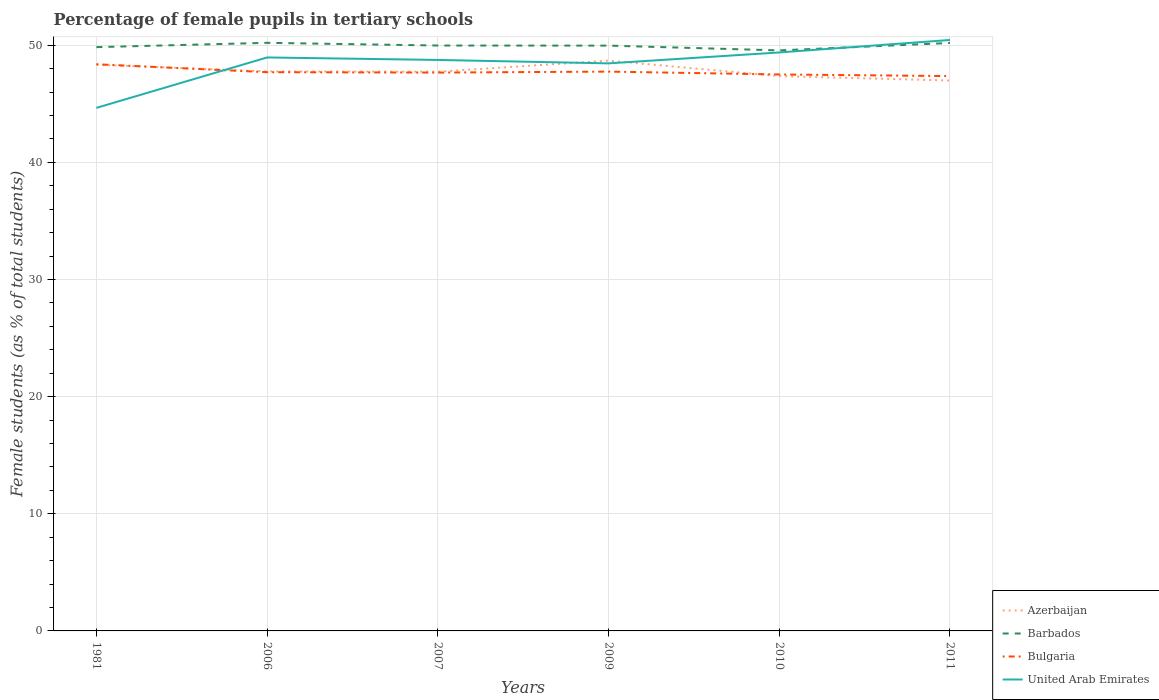How many different coloured lines are there?
Provide a short and direct response. 4. Across all years, what is the maximum percentage of female pupils in tertiary schools in Azerbaijan?
Provide a succinct answer. 46.99. What is the total percentage of female pupils in tertiary schools in Azerbaijan in the graph?
Offer a terse response. -0.92. What is the difference between the highest and the second highest percentage of female pupils in tertiary schools in Bulgaria?
Give a very brief answer. 1.01. What is the difference between the highest and the lowest percentage of female pupils in tertiary schools in United Arab Emirates?
Give a very brief answer. 5. Is the percentage of female pupils in tertiary schools in Bulgaria strictly greater than the percentage of female pupils in tertiary schools in Azerbaijan over the years?
Ensure brevity in your answer.  No. How many lines are there?
Make the answer very short. 4. Are the values on the major ticks of Y-axis written in scientific E-notation?
Provide a succinct answer. No. What is the title of the graph?
Make the answer very short. Percentage of female pupils in tertiary schools. What is the label or title of the X-axis?
Offer a very short reply. Years. What is the label or title of the Y-axis?
Your response must be concise. Female students (as % of total students). What is the Female students (as % of total students) in Azerbaijan in 1981?
Your answer should be very brief. 48.34. What is the Female students (as % of total students) in Barbados in 1981?
Your response must be concise. 49.84. What is the Female students (as % of total students) in Bulgaria in 1981?
Ensure brevity in your answer.  48.38. What is the Female students (as % of total students) of United Arab Emirates in 1981?
Keep it short and to the point. 44.65. What is the Female students (as % of total students) of Azerbaijan in 2006?
Give a very brief answer. 47.77. What is the Female students (as % of total students) of Barbados in 2006?
Your answer should be very brief. 50.21. What is the Female students (as % of total students) in Bulgaria in 2006?
Provide a short and direct response. 47.7. What is the Female students (as % of total students) of United Arab Emirates in 2006?
Provide a succinct answer. 48.96. What is the Female students (as % of total students) of Azerbaijan in 2007?
Offer a terse response. 47.74. What is the Female students (as % of total students) of Barbados in 2007?
Make the answer very short. 49.98. What is the Female students (as % of total students) of Bulgaria in 2007?
Your answer should be compact. 47.67. What is the Female students (as % of total students) in United Arab Emirates in 2007?
Ensure brevity in your answer.  48.75. What is the Female students (as % of total students) in Azerbaijan in 2009?
Ensure brevity in your answer.  48.69. What is the Female students (as % of total students) of Barbados in 2009?
Keep it short and to the point. 49.97. What is the Female students (as % of total students) of Bulgaria in 2009?
Your answer should be very brief. 47.75. What is the Female students (as % of total students) of United Arab Emirates in 2009?
Provide a short and direct response. 48.46. What is the Female students (as % of total students) in Azerbaijan in 2010?
Your answer should be very brief. 47.37. What is the Female students (as % of total students) in Barbados in 2010?
Provide a succinct answer. 49.56. What is the Female students (as % of total students) of Bulgaria in 2010?
Offer a terse response. 47.51. What is the Female students (as % of total students) in United Arab Emirates in 2010?
Provide a short and direct response. 49.39. What is the Female students (as % of total students) of Azerbaijan in 2011?
Your response must be concise. 46.99. What is the Female students (as % of total students) of Barbados in 2011?
Offer a very short reply. 50.2. What is the Female students (as % of total students) in Bulgaria in 2011?
Keep it short and to the point. 47.37. What is the Female students (as % of total students) of United Arab Emirates in 2011?
Ensure brevity in your answer.  50.45. Across all years, what is the maximum Female students (as % of total students) of Azerbaijan?
Ensure brevity in your answer.  48.69. Across all years, what is the maximum Female students (as % of total students) in Barbados?
Provide a succinct answer. 50.21. Across all years, what is the maximum Female students (as % of total students) of Bulgaria?
Give a very brief answer. 48.38. Across all years, what is the maximum Female students (as % of total students) of United Arab Emirates?
Make the answer very short. 50.45. Across all years, what is the minimum Female students (as % of total students) in Azerbaijan?
Your response must be concise. 46.99. Across all years, what is the minimum Female students (as % of total students) of Barbados?
Your response must be concise. 49.56. Across all years, what is the minimum Female students (as % of total students) of Bulgaria?
Offer a terse response. 47.37. Across all years, what is the minimum Female students (as % of total students) of United Arab Emirates?
Give a very brief answer. 44.65. What is the total Female students (as % of total students) of Azerbaijan in the graph?
Provide a short and direct response. 286.9. What is the total Female students (as % of total students) of Barbados in the graph?
Ensure brevity in your answer.  299.76. What is the total Female students (as % of total students) in Bulgaria in the graph?
Your answer should be very brief. 286.38. What is the total Female students (as % of total students) of United Arab Emirates in the graph?
Ensure brevity in your answer.  290.66. What is the difference between the Female students (as % of total students) in Azerbaijan in 1981 and that in 2006?
Offer a very short reply. 0.57. What is the difference between the Female students (as % of total students) of Barbados in 1981 and that in 2006?
Your answer should be very brief. -0.37. What is the difference between the Female students (as % of total students) of Bulgaria in 1981 and that in 2006?
Give a very brief answer. 0.68. What is the difference between the Female students (as % of total students) in United Arab Emirates in 1981 and that in 2006?
Provide a short and direct response. -4.3. What is the difference between the Female students (as % of total students) of Azerbaijan in 1981 and that in 2007?
Make the answer very short. 0.59. What is the difference between the Female students (as % of total students) of Barbados in 1981 and that in 2007?
Make the answer very short. -0.14. What is the difference between the Female students (as % of total students) in Bulgaria in 1981 and that in 2007?
Ensure brevity in your answer.  0.71. What is the difference between the Female students (as % of total students) in United Arab Emirates in 1981 and that in 2007?
Ensure brevity in your answer.  -4.09. What is the difference between the Female students (as % of total students) in Azerbaijan in 1981 and that in 2009?
Your answer should be compact. -0.35. What is the difference between the Female students (as % of total students) of Barbados in 1981 and that in 2009?
Keep it short and to the point. -0.13. What is the difference between the Female students (as % of total students) of Bulgaria in 1981 and that in 2009?
Ensure brevity in your answer.  0.63. What is the difference between the Female students (as % of total students) of United Arab Emirates in 1981 and that in 2009?
Offer a terse response. -3.8. What is the difference between the Female students (as % of total students) in Azerbaijan in 1981 and that in 2010?
Your answer should be compact. 0.97. What is the difference between the Female students (as % of total students) of Barbados in 1981 and that in 2010?
Offer a very short reply. 0.28. What is the difference between the Female students (as % of total students) in Bulgaria in 1981 and that in 2010?
Ensure brevity in your answer.  0.87. What is the difference between the Female students (as % of total students) in United Arab Emirates in 1981 and that in 2010?
Your response must be concise. -4.73. What is the difference between the Female students (as % of total students) of Azerbaijan in 1981 and that in 2011?
Keep it short and to the point. 1.35. What is the difference between the Female students (as % of total students) of Barbados in 1981 and that in 2011?
Your answer should be very brief. -0.36. What is the difference between the Female students (as % of total students) in Bulgaria in 1981 and that in 2011?
Offer a very short reply. 1.01. What is the difference between the Female students (as % of total students) of United Arab Emirates in 1981 and that in 2011?
Make the answer very short. -5.8. What is the difference between the Female students (as % of total students) of Azerbaijan in 2006 and that in 2007?
Offer a very short reply. 0.02. What is the difference between the Female students (as % of total students) in Barbados in 2006 and that in 2007?
Provide a succinct answer. 0.23. What is the difference between the Female students (as % of total students) of Bulgaria in 2006 and that in 2007?
Provide a short and direct response. 0.03. What is the difference between the Female students (as % of total students) in United Arab Emirates in 2006 and that in 2007?
Offer a very short reply. 0.21. What is the difference between the Female students (as % of total students) in Azerbaijan in 2006 and that in 2009?
Your response must be concise. -0.92. What is the difference between the Female students (as % of total students) in Barbados in 2006 and that in 2009?
Your answer should be very brief. 0.24. What is the difference between the Female students (as % of total students) of Bulgaria in 2006 and that in 2009?
Provide a succinct answer. -0.05. What is the difference between the Female students (as % of total students) in United Arab Emirates in 2006 and that in 2009?
Provide a short and direct response. 0.5. What is the difference between the Female students (as % of total students) in Azerbaijan in 2006 and that in 2010?
Ensure brevity in your answer.  0.4. What is the difference between the Female students (as % of total students) of Barbados in 2006 and that in 2010?
Provide a short and direct response. 0.65. What is the difference between the Female students (as % of total students) in Bulgaria in 2006 and that in 2010?
Provide a succinct answer. 0.2. What is the difference between the Female students (as % of total students) of United Arab Emirates in 2006 and that in 2010?
Give a very brief answer. -0.43. What is the difference between the Female students (as % of total students) of Azerbaijan in 2006 and that in 2011?
Make the answer very short. 0.78. What is the difference between the Female students (as % of total students) in Barbados in 2006 and that in 2011?
Provide a short and direct response. 0.01. What is the difference between the Female students (as % of total students) of Bulgaria in 2006 and that in 2011?
Your answer should be very brief. 0.33. What is the difference between the Female students (as % of total students) of United Arab Emirates in 2006 and that in 2011?
Your answer should be compact. -1.49. What is the difference between the Female students (as % of total students) of Azerbaijan in 2007 and that in 2009?
Offer a very short reply. -0.94. What is the difference between the Female students (as % of total students) of Barbados in 2007 and that in 2009?
Your answer should be very brief. 0.01. What is the difference between the Female students (as % of total students) of Bulgaria in 2007 and that in 2009?
Your response must be concise. -0.08. What is the difference between the Female students (as % of total students) of United Arab Emirates in 2007 and that in 2009?
Ensure brevity in your answer.  0.29. What is the difference between the Female students (as % of total students) in Azerbaijan in 2007 and that in 2010?
Provide a succinct answer. 0.38. What is the difference between the Female students (as % of total students) of Barbados in 2007 and that in 2010?
Offer a terse response. 0.42. What is the difference between the Female students (as % of total students) of Bulgaria in 2007 and that in 2010?
Your answer should be very brief. 0.16. What is the difference between the Female students (as % of total students) of United Arab Emirates in 2007 and that in 2010?
Keep it short and to the point. -0.64. What is the difference between the Female students (as % of total students) in Azerbaijan in 2007 and that in 2011?
Make the answer very short. 0.75. What is the difference between the Female students (as % of total students) of Barbados in 2007 and that in 2011?
Keep it short and to the point. -0.22. What is the difference between the Female students (as % of total students) in Bulgaria in 2007 and that in 2011?
Your response must be concise. 0.3. What is the difference between the Female students (as % of total students) of United Arab Emirates in 2007 and that in 2011?
Your response must be concise. -1.7. What is the difference between the Female students (as % of total students) of Azerbaijan in 2009 and that in 2010?
Ensure brevity in your answer.  1.32. What is the difference between the Female students (as % of total students) of Barbados in 2009 and that in 2010?
Your answer should be very brief. 0.41. What is the difference between the Female students (as % of total students) in Bulgaria in 2009 and that in 2010?
Make the answer very short. 0.24. What is the difference between the Female students (as % of total students) in United Arab Emirates in 2009 and that in 2010?
Ensure brevity in your answer.  -0.93. What is the difference between the Female students (as % of total students) in Azerbaijan in 2009 and that in 2011?
Give a very brief answer. 1.7. What is the difference between the Female students (as % of total students) in Barbados in 2009 and that in 2011?
Provide a succinct answer. -0.23. What is the difference between the Female students (as % of total students) of Bulgaria in 2009 and that in 2011?
Provide a succinct answer. 0.38. What is the difference between the Female students (as % of total students) of United Arab Emirates in 2009 and that in 2011?
Offer a very short reply. -2. What is the difference between the Female students (as % of total students) in Azerbaijan in 2010 and that in 2011?
Keep it short and to the point. 0.38. What is the difference between the Female students (as % of total students) of Barbados in 2010 and that in 2011?
Offer a terse response. -0.64. What is the difference between the Female students (as % of total students) of Bulgaria in 2010 and that in 2011?
Your answer should be very brief. 0.14. What is the difference between the Female students (as % of total students) of United Arab Emirates in 2010 and that in 2011?
Ensure brevity in your answer.  -1.07. What is the difference between the Female students (as % of total students) of Azerbaijan in 1981 and the Female students (as % of total students) of Barbados in 2006?
Your response must be concise. -1.87. What is the difference between the Female students (as % of total students) of Azerbaijan in 1981 and the Female students (as % of total students) of Bulgaria in 2006?
Offer a very short reply. 0.63. What is the difference between the Female students (as % of total students) of Azerbaijan in 1981 and the Female students (as % of total students) of United Arab Emirates in 2006?
Offer a very short reply. -0.62. What is the difference between the Female students (as % of total students) of Barbados in 1981 and the Female students (as % of total students) of Bulgaria in 2006?
Offer a terse response. 2.14. What is the difference between the Female students (as % of total students) in Barbados in 1981 and the Female students (as % of total students) in United Arab Emirates in 2006?
Your response must be concise. 0.88. What is the difference between the Female students (as % of total students) in Bulgaria in 1981 and the Female students (as % of total students) in United Arab Emirates in 2006?
Offer a terse response. -0.58. What is the difference between the Female students (as % of total students) in Azerbaijan in 1981 and the Female students (as % of total students) in Barbados in 2007?
Make the answer very short. -1.64. What is the difference between the Female students (as % of total students) in Azerbaijan in 1981 and the Female students (as % of total students) in Bulgaria in 2007?
Keep it short and to the point. 0.67. What is the difference between the Female students (as % of total students) of Azerbaijan in 1981 and the Female students (as % of total students) of United Arab Emirates in 2007?
Provide a succinct answer. -0.41. What is the difference between the Female students (as % of total students) in Barbados in 1981 and the Female students (as % of total students) in Bulgaria in 2007?
Offer a very short reply. 2.17. What is the difference between the Female students (as % of total students) of Barbados in 1981 and the Female students (as % of total students) of United Arab Emirates in 2007?
Keep it short and to the point. 1.09. What is the difference between the Female students (as % of total students) in Bulgaria in 1981 and the Female students (as % of total students) in United Arab Emirates in 2007?
Your answer should be very brief. -0.37. What is the difference between the Female students (as % of total students) in Azerbaijan in 1981 and the Female students (as % of total students) in Barbados in 2009?
Your answer should be compact. -1.63. What is the difference between the Female students (as % of total students) in Azerbaijan in 1981 and the Female students (as % of total students) in Bulgaria in 2009?
Your response must be concise. 0.58. What is the difference between the Female students (as % of total students) of Azerbaijan in 1981 and the Female students (as % of total students) of United Arab Emirates in 2009?
Provide a short and direct response. -0.12. What is the difference between the Female students (as % of total students) in Barbados in 1981 and the Female students (as % of total students) in Bulgaria in 2009?
Make the answer very short. 2.09. What is the difference between the Female students (as % of total students) of Barbados in 1981 and the Female students (as % of total students) of United Arab Emirates in 2009?
Your response must be concise. 1.38. What is the difference between the Female students (as % of total students) of Bulgaria in 1981 and the Female students (as % of total students) of United Arab Emirates in 2009?
Keep it short and to the point. -0.08. What is the difference between the Female students (as % of total students) in Azerbaijan in 1981 and the Female students (as % of total students) in Barbados in 2010?
Offer a very short reply. -1.23. What is the difference between the Female students (as % of total students) of Azerbaijan in 1981 and the Female students (as % of total students) of Bulgaria in 2010?
Ensure brevity in your answer.  0.83. What is the difference between the Female students (as % of total students) in Azerbaijan in 1981 and the Female students (as % of total students) in United Arab Emirates in 2010?
Make the answer very short. -1.05. What is the difference between the Female students (as % of total students) of Barbados in 1981 and the Female students (as % of total students) of Bulgaria in 2010?
Provide a succinct answer. 2.33. What is the difference between the Female students (as % of total students) in Barbados in 1981 and the Female students (as % of total students) in United Arab Emirates in 2010?
Provide a succinct answer. 0.45. What is the difference between the Female students (as % of total students) in Bulgaria in 1981 and the Female students (as % of total students) in United Arab Emirates in 2010?
Make the answer very short. -1.01. What is the difference between the Female students (as % of total students) of Azerbaijan in 1981 and the Female students (as % of total students) of Barbados in 2011?
Your response must be concise. -1.86. What is the difference between the Female students (as % of total students) in Azerbaijan in 1981 and the Female students (as % of total students) in Bulgaria in 2011?
Your answer should be compact. 0.97. What is the difference between the Female students (as % of total students) in Azerbaijan in 1981 and the Female students (as % of total students) in United Arab Emirates in 2011?
Offer a very short reply. -2.12. What is the difference between the Female students (as % of total students) in Barbados in 1981 and the Female students (as % of total students) in Bulgaria in 2011?
Make the answer very short. 2.47. What is the difference between the Female students (as % of total students) of Barbados in 1981 and the Female students (as % of total students) of United Arab Emirates in 2011?
Offer a terse response. -0.61. What is the difference between the Female students (as % of total students) in Bulgaria in 1981 and the Female students (as % of total students) in United Arab Emirates in 2011?
Your answer should be very brief. -2.07. What is the difference between the Female students (as % of total students) of Azerbaijan in 2006 and the Female students (as % of total students) of Barbados in 2007?
Provide a short and direct response. -2.21. What is the difference between the Female students (as % of total students) in Azerbaijan in 2006 and the Female students (as % of total students) in Bulgaria in 2007?
Provide a succinct answer. 0.1. What is the difference between the Female students (as % of total students) of Azerbaijan in 2006 and the Female students (as % of total students) of United Arab Emirates in 2007?
Keep it short and to the point. -0.98. What is the difference between the Female students (as % of total students) of Barbados in 2006 and the Female students (as % of total students) of Bulgaria in 2007?
Offer a terse response. 2.54. What is the difference between the Female students (as % of total students) of Barbados in 2006 and the Female students (as % of total students) of United Arab Emirates in 2007?
Provide a succinct answer. 1.46. What is the difference between the Female students (as % of total students) of Bulgaria in 2006 and the Female students (as % of total students) of United Arab Emirates in 2007?
Provide a short and direct response. -1.05. What is the difference between the Female students (as % of total students) in Azerbaijan in 2006 and the Female students (as % of total students) in Barbados in 2009?
Your answer should be very brief. -2.2. What is the difference between the Female students (as % of total students) of Azerbaijan in 2006 and the Female students (as % of total students) of Bulgaria in 2009?
Your answer should be compact. 0.02. What is the difference between the Female students (as % of total students) in Azerbaijan in 2006 and the Female students (as % of total students) in United Arab Emirates in 2009?
Make the answer very short. -0.69. What is the difference between the Female students (as % of total students) of Barbados in 2006 and the Female students (as % of total students) of Bulgaria in 2009?
Your response must be concise. 2.46. What is the difference between the Female students (as % of total students) in Barbados in 2006 and the Female students (as % of total students) in United Arab Emirates in 2009?
Provide a short and direct response. 1.75. What is the difference between the Female students (as % of total students) of Bulgaria in 2006 and the Female students (as % of total students) of United Arab Emirates in 2009?
Provide a succinct answer. -0.75. What is the difference between the Female students (as % of total students) in Azerbaijan in 2006 and the Female students (as % of total students) in Barbados in 2010?
Offer a very short reply. -1.79. What is the difference between the Female students (as % of total students) of Azerbaijan in 2006 and the Female students (as % of total students) of Bulgaria in 2010?
Offer a terse response. 0.26. What is the difference between the Female students (as % of total students) in Azerbaijan in 2006 and the Female students (as % of total students) in United Arab Emirates in 2010?
Give a very brief answer. -1.62. What is the difference between the Female students (as % of total students) in Barbados in 2006 and the Female students (as % of total students) in Bulgaria in 2010?
Provide a short and direct response. 2.7. What is the difference between the Female students (as % of total students) of Barbados in 2006 and the Female students (as % of total students) of United Arab Emirates in 2010?
Offer a very short reply. 0.82. What is the difference between the Female students (as % of total students) in Bulgaria in 2006 and the Female students (as % of total students) in United Arab Emirates in 2010?
Your answer should be compact. -1.68. What is the difference between the Female students (as % of total students) of Azerbaijan in 2006 and the Female students (as % of total students) of Barbados in 2011?
Ensure brevity in your answer.  -2.43. What is the difference between the Female students (as % of total students) of Azerbaijan in 2006 and the Female students (as % of total students) of Bulgaria in 2011?
Offer a very short reply. 0.4. What is the difference between the Female students (as % of total students) of Azerbaijan in 2006 and the Female students (as % of total students) of United Arab Emirates in 2011?
Keep it short and to the point. -2.68. What is the difference between the Female students (as % of total students) of Barbados in 2006 and the Female students (as % of total students) of Bulgaria in 2011?
Provide a succinct answer. 2.84. What is the difference between the Female students (as % of total students) in Barbados in 2006 and the Female students (as % of total students) in United Arab Emirates in 2011?
Offer a very short reply. -0.24. What is the difference between the Female students (as % of total students) in Bulgaria in 2006 and the Female students (as % of total students) in United Arab Emirates in 2011?
Give a very brief answer. -2.75. What is the difference between the Female students (as % of total students) in Azerbaijan in 2007 and the Female students (as % of total students) in Barbados in 2009?
Your answer should be compact. -2.23. What is the difference between the Female students (as % of total students) in Azerbaijan in 2007 and the Female students (as % of total students) in Bulgaria in 2009?
Provide a succinct answer. -0.01. What is the difference between the Female students (as % of total students) in Azerbaijan in 2007 and the Female students (as % of total students) in United Arab Emirates in 2009?
Your answer should be compact. -0.71. What is the difference between the Female students (as % of total students) of Barbados in 2007 and the Female students (as % of total students) of Bulgaria in 2009?
Your answer should be very brief. 2.23. What is the difference between the Female students (as % of total students) in Barbados in 2007 and the Female students (as % of total students) in United Arab Emirates in 2009?
Offer a very short reply. 1.52. What is the difference between the Female students (as % of total students) in Bulgaria in 2007 and the Female students (as % of total students) in United Arab Emirates in 2009?
Provide a succinct answer. -0.79. What is the difference between the Female students (as % of total students) in Azerbaijan in 2007 and the Female students (as % of total students) in Barbados in 2010?
Make the answer very short. -1.82. What is the difference between the Female students (as % of total students) in Azerbaijan in 2007 and the Female students (as % of total students) in Bulgaria in 2010?
Make the answer very short. 0.24. What is the difference between the Female students (as % of total students) of Azerbaijan in 2007 and the Female students (as % of total students) of United Arab Emirates in 2010?
Your response must be concise. -1.64. What is the difference between the Female students (as % of total students) in Barbados in 2007 and the Female students (as % of total students) in Bulgaria in 2010?
Make the answer very short. 2.47. What is the difference between the Female students (as % of total students) of Barbados in 2007 and the Female students (as % of total students) of United Arab Emirates in 2010?
Provide a short and direct response. 0.59. What is the difference between the Female students (as % of total students) of Bulgaria in 2007 and the Female students (as % of total students) of United Arab Emirates in 2010?
Make the answer very short. -1.72. What is the difference between the Female students (as % of total students) in Azerbaijan in 2007 and the Female students (as % of total students) in Barbados in 2011?
Keep it short and to the point. -2.45. What is the difference between the Female students (as % of total students) of Azerbaijan in 2007 and the Female students (as % of total students) of Bulgaria in 2011?
Make the answer very short. 0.38. What is the difference between the Female students (as % of total students) in Azerbaijan in 2007 and the Female students (as % of total students) in United Arab Emirates in 2011?
Keep it short and to the point. -2.71. What is the difference between the Female students (as % of total students) in Barbados in 2007 and the Female students (as % of total students) in Bulgaria in 2011?
Offer a terse response. 2.61. What is the difference between the Female students (as % of total students) of Barbados in 2007 and the Female students (as % of total students) of United Arab Emirates in 2011?
Offer a terse response. -0.47. What is the difference between the Female students (as % of total students) of Bulgaria in 2007 and the Female students (as % of total students) of United Arab Emirates in 2011?
Your answer should be compact. -2.78. What is the difference between the Female students (as % of total students) in Azerbaijan in 2009 and the Female students (as % of total students) in Barbados in 2010?
Offer a very short reply. -0.87. What is the difference between the Female students (as % of total students) in Azerbaijan in 2009 and the Female students (as % of total students) in Bulgaria in 2010?
Give a very brief answer. 1.18. What is the difference between the Female students (as % of total students) of Azerbaijan in 2009 and the Female students (as % of total students) of United Arab Emirates in 2010?
Your answer should be compact. -0.7. What is the difference between the Female students (as % of total students) in Barbados in 2009 and the Female students (as % of total students) in Bulgaria in 2010?
Provide a short and direct response. 2.46. What is the difference between the Female students (as % of total students) of Barbados in 2009 and the Female students (as % of total students) of United Arab Emirates in 2010?
Ensure brevity in your answer.  0.58. What is the difference between the Female students (as % of total students) in Bulgaria in 2009 and the Female students (as % of total students) in United Arab Emirates in 2010?
Your answer should be compact. -1.64. What is the difference between the Female students (as % of total students) in Azerbaijan in 2009 and the Female students (as % of total students) in Barbados in 2011?
Give a very brief answer. -1.51. What is the difference between the Female students (as % of total students) of Azerbaijan in 2009 and the Female students (as % of total students) of Bulgaria in 2011?
Keep it short and to the point. 1.32. What is the difference between the Female students (as % of total students) of Azerbaijan in 2009 and the Female students (as % of total students) of United Arab Emirates in 2011?
Provide a short and direct response. -1.76. What is the difference between the Female students (as % of total students) of Barbados in 2009 and the Female students (as % of total students) of Bulgaria in 2011?
Ensure brevity in your answer.  2.6. What is the difference between the Female students (as % of total students) of Barbados in 2009 and the Female students (as % of total students) of United Arab Emirates in 2011?
Make the answer very short. -0.48. What is the difference between the Female students (as % of total students) in Bulgaria in 2009 and the Female students (as % of total students) in United Arab Emirates in 2011?
Your answer should be compact. -2.7. What is the difference between the Female students (as % of total students) in Azerbaijan in 2010 and the Female students (as % of total students) in Barbados in 2011?
Your answer should be compact. -2.83. What is the difference between the Female students (as % of total students) of Azerbaijan in 2010 and the Female students (as % of total students) of Bulgaria in 2011?
Provide a short and direct response. -0. What is the difference between the Female students (as % of total students) in Azerbaijan in 2010 and the Female students (as % of total students) in United Arab Emirates in 2011?
Offer a very short reply. -3.09. What is the difference between the Female students (as % of total students) in Barbados in 2010 and the Female students (as % of total students) in Bulgaria in 2011?
Your answer should be compact. 2.19. What is the difference between the Female students (as % of total students) of Barbados in 2010 and the Female students (as % of total students) of United Arab Emirates in 2011?
Give a very brief answer. -0.89. What is the difference between the Female students (as % of total students) of Bulgaria in 2010 and the Female students (as % of total students) of United Arab Emirates in 2011?
Your answer should be compact. -2.95. What is the average Female students (as % of total students) in Azerbaijan per year?
Provide a short and direct response. 47.82. What is the average Female students (as % of total students) of Barbados per year?
Make the answer very short. 49.96. What is the average Female students (as % of total students) of Bulgaria per year?
Your answer should be very brief. 47.73. What is the average Female students (as % of total students) in United Arab Emirates per year?
Make the answer very short. 48.44. In the year 1981, what is the difference between the Female students (as % of total students) of Azerbaijan and Female students (as % of total students) of Barbados?
Give a very brief answer. -1.5. In the year 1981, what is the difference between the Female students (as % of total students) of Azerbaijan and Female students (as % of total students) of Bulgaria?
Offer a terse response. -0.04. In the year 1981, what is the difference between the Female students (as % of total students) of Azerbaijan and Female students (as % of total students) of United Arab Emirates?
Offer a terse response. 3.68. In the year 1981, what is the difference between the Female students (as % of total students) in Barbados and Female students (as % of total students) in Bulgaria?
Your answer should be very brief. 1.46. In the year 1981, what is the difference between the Female students (as % of total students) of Barbados and Female students (as % of total students) of United Arab Emirates?
Provide a succinct answer. 5.19. In the year 1981, what is the difference between the Female students (as % of total students) in Bulgaria and Female students (as % of total students) in United Arab Emirates?
Provide a short and direct response. 3.73. In the year 2006, what is the difference between the Female students (as % of total students) of Azerbaijan and Female students (as % of total students) of Barbados?
Give a very brief answer. -2.44. In the year 2006, what is the difference between the Female students (as % of total students) of Azerbaijan and Female students (as % of total students) of Bulgaria?
Your answer should be compact. 0.07. In the year 2006, what is the difference between the Female students (as % of total students) of Azerbaijan and Female students (as % of total students) of United Arab Emirates?
Ensure brevity in your answer.  -1.19. In the year 2006, what is the difference between the Female students (as % of total students) of Barbados and Female students (as % of total students) of Bulgaria?
Your answer should be compact. 2.51. In the year 2006, what is the difference between the Female students (as % of total students) in Barbados and Female students (as % of total students) in United Arab Emirates?
Ensure brevity in your answer.  1.25. In the year 2006, what is the difference between the Female students (as % of total students) in Bulgaria and Female students (as % of total students) in United Arab Emirates?
Keep it short and to the point. -1.26. In the year 2007, what is the difference between the Female students (as % of total students) in Azerbaijan and Female students (as % of total students) in Barbados?
Keep it short and to the point. -2.23. In the year 2007, what is the difference between the Female students (as % of total students) of Azerbaijan and Female students (as % of total students) of Bulgaria?
Offer a very short reply. 0.08. In the year 2007, what is the difference between the Female students (as % of total students) of Azerbaijan and Female students (as % of total students) of United Arab Emirates?
Your answer should be compact. -1. In the year 2007, what is the difference between the Female students (as % of total students) of Barbados and Female students (as % of total students) of Bulgaria?
Give a very brief answer. 2.31. In the year 2007, what is the difference between the Female students (as % of total students) in Barbados and Female students (as % of total students) in United Arab Emirates?
Provide a short and direct response. 1.23. In the year 2007, what is the difference between the Female students (as % of total students) in Bulgaria and Female students (as % of total students) in United Arab Emirates?
Give a very brief answer. -1.08. In the year 2009, what is the difference between the Female students (as % of total students) of Azerbaijan and Female students (as % of total students) of Barbados?
Offer a terse response. -1.28. In the year 2009, what is the difference between the Female students (as % of total students) of Azerbaijan and Female students (as % of total students) of Bulgaria?
Your answer should be very brief. 0.94. In the year 2009, what is the difference between the Female students (as % of total students) of Azerbaijan and Female students (as % of total students) of United Arab Emirates?
Offer a very short reply. 0.23. In the year 2009, what is the difference between the Female students (as % of total students) in Barbados and Female students (as % of total students) in Bulgaria?
Your answer should be very brief. 2.22. In the year 2009, what is the difference between the Female students (as % of total students) in Barbados and Female students (as % of total students) in United Arab Emirates?
Offer a terse response. 1.51. In the year 2009, what is the difference between the Female students (as % of total students) of Bulgaria and Female students (as % of total students) of United Arab Emirates?
Keep it short and to the point. -0.7. In the year 2010, what is the difference between the Female students (as % of total students) of Azerbaijan and Female students (as % of total students) of Barbados?
Keep it short and to the point. -2.19. In the year 2010, what is the difference between the Female students (as % of total students) in Azerbaijan and Female students (as % of total students) in Bulgaria?
Keep it short and to the point. -0.14. In the year 2010, what is the difference between the Female students (as % of total students) of Azerbaijan and Female students (as % of total students) of United Arab Emirates?
Your answer should be compact. -2.02. In the year 2010, what is the difference between the Female students (as % of total students) of Barbados and Female students (as % of total students) of Bulgaria?
Your answer should be compact. 2.05. In the year 2010, what is the difference between the Female students (as % of total students) of Barbados and Female students (as % of total students) of United Arab Emirates?
Offer a terse response. 0.17. In the year 2010, what is the difference between the Female students (as % of total students) of Bulgaria and Female students (as % of total students) of United Arab Emirates?
Make the answer very short. -1.88. In the year 2011, what is the difference between the Female students (as % of total students) of Azerbaijan and Female students (as % of total students) of Barbados?
Provide a succinct answer. -3.21. In the year 2011, what is the difference between the Female students (as % of total students) of Azerbaijan and Female students (as % of total students) of Bulgaria?
Keep it short and to the point. -0.38. In the year 2011, what is the difference between the Female students (as % of total students) in Azerbaijan and Female students (as % of total students) in United Arab Emirates?
Offer a very short reply. -3.46. In the year 2011, what is the difference between the Female students (as % of total students) of Barbados and Female students (as % of total students) of Bulgaria?
Provide a short and direct response. 2.83. In the year 2011, what is the difference between the Female students (as % of total students) in Barbados and Female students (as % of total students) in United Arab Emirates?
Give a very brief answer. -0.25. In the year 2011, what is the difference between the Female students (as % of total students) of Bulgaria and Female students (as % of total students) of United Arab Emirates?
Ensure brevity in your answer.  -3.08. What is the ratio of the Female students (as % of total students) of Azerbaijan in 1981 to that in 2006?
Offer a terse response. 1.01. What is the ratio of the Female students (as % of total students) of Barbados in 1981 to that in 2006?
Your response must be concise. 0.99. What is the ratio of the Female students (as % of total students) of Bulgaria in 1981 to that in 2006?
Offer a very short reply. 1.01. What is the ratio of the Female students (as % of total students) in United Arab Emirates in 1981 to that in 2006?
Your answer should be very brief. 0.91. What is the ratio of the Female students (as % of total students) of Azerbaijan in 1981 to that in 2007?
Offer a very short reply. 1.01. What is the ratio of the Female students (as % of total students) of Bulgaria in 1981 to that in 2007?
Provide a succinct answer. 1.01. What is the ratio of the Female students (as % of total students) of United Arab Emirates in 1981 to that in 2007?
Make the answer very short. 0.92. What is the ratio of the Female students (as % of total students) in Barbados in 1981 to that in 2009?
Offer a very short reply. 1. What is the ratio of the Female students (as % of total students) of Bulgaria in 1981 to that in 2009?
Keep it short and to the point. 1.01. What is the ratio of the Female students (as % of total students) of United Arab Emirates in 1981 to that in 2009?
Ensure brevity in your answer.  0.92. What is the ratio of the Female students (as % of total students) of Azerbaijan in 1981 to that in 2010?
Provide a short and direct response. 1.02. What is the ratio of the Female students (as % of total students) of Barbados in 1981 to that in 2010?
Give a very brief answer. 1.01. What is the ratio of the Female students (as % of total students) in Bulgaria in 1981 to that in 2010?
Your answer should be very brief. 1.02. What is the ratio of the Female students (as % of total students) of United Arab Emirates in 1981 to that in 2010?
Offer a terse response. 0.9. What is the ratio of the Female students (as % of total students) in Azerbaijan in 1981 to that in 2011?
Provide a succinct answer. 1.03. What is the ratio of the Female students (as % of total students) in Barbados in 1981 to that in 2011?
Give a very brief answer. 0.99. What is the ratio of the Female students (as % of total students) in Bulgaria in 1981 to that in 2011?
Keep it short and to the point. 1.02. What is the ratio of the Female students (as % of total students) of United Arab Emirates in 1981 to that in 2011?
Offer a terse response. 0.89. What is the ratio of the Female students (as % of total students) in Azerbaijan in 2006 to that in 2007?
Your answer should be very brief. 1. What is the ratio of the Female students (as % of total students) in Barbados in 2006 to that in 2007?
Offer a terse response. 1. What is the ratio of the Female students (as % of total students) in Bulgaria in 2006 to that in 2007?
Provide a short and direct response. 1. What is the ratio of the Female students (as % of total students) of United Arab Emirates in 2006 to that in 2007?
Give a very brief answer. 1. What is the ratio of the Female students (as % of total students) in Azerbaijan in 2006 to that in 2009?
Ensure brevity in your answer.  0.98. What is the ratio of the Female students (as % of total students) of United Arab Emirates in 2006 to that in 2009?
Your response must be concise. 1.01. What is the ratio of the Female students (as % of total students) in Azerbaijan in 2006 to that in 2010?
Offer a terse response. 1.01. What is the ratio of the Female students (as % of total students) in Barbados in 2006 to that in 2010?
Keep it short and to the point. 1.01. What is the ratio of the Female students (as % of total students) in Bulgaria in 2006 to that in 2010?
Keep it short and to the point. 1. What is the ratio of the Female students (as % of total students) in Azerbaijan in 2006 to that in 2011?
Offer a very short reply. 1.02. What is the ratio of the Female students (as % of total students) in Bulgaria in 2006 to that in 2011?
Provide a succinct answer. 1.01. What is the ratio of the Female students (as % of total students) of United Arab Emirates in 2006 to that in 2011?
Keep it short and to the point. 0.97. What is the ratio of the Female students (as % of total students) in Azerbaijan in 2007 to that in 2009?
Offer a terse response. 0.98. What is the ratio of the Female students (as % of total students) of Bulgaria in 2007 to that in 2009?
Your answer should be compact. 1. What is the ratio of the Female students (as % of total students) of Barbados in 2007 to that in 2010?
Provide a succinct answer. 1.01. What is the ratio of the Female students (as % of total students) in Bulgaria in 2007 to that in 2010?
Provide a short and direct response. 1. What is the ratio of the Female students (as % of total students) of United Arab Emirates in 2007 to that in 2010?
Give a very brief answer. 0.99. What is the ratio of the Female students (as % of total students) of Bulgaria in 2007 to that in 2011?
Your response must be concise. 1.01. What is the ratio of the Female students (as % of total students) in United Arab Emirates in 2007 to that in 2011?
Provide a short and direct response. 0.97. What is the ratio of the Female students (as % of total students) of Azerbaijan in 2009 to that in 2010?
Ensure brevity in your answer.  1.03. What is the ratio of the Female students (as % of total students) in Barbados in 2009 to that in 2010?
Your answer should be very brief. 1.01. What is the ratio of the Female students (as % of total students) in United Arab Emirates in 2009 to that in 2010?
Give a very brief answer. 0.98. What is the ratio of the Female students (as % of total students) in Azerbaijan in 2009 to that in 2011?
Your response must be concise. 1.04. What is the ratio of the Female students (as % of total students) of Barbados in 2009 to that in 2011?
Your response must be concise. 1. What is the ratio of the Female students (as % of total students) in Bulgaria in 2009 to that in 2011?
Give a very brief answer. 1.01. What is the ratio of the Female students (as % of total students) in United Arab Emirates in 2009 to that in 2011?
Your answer should be very brief. 0.96. What is the ratio of the Female students (as % of total students) of Barbados in 2010 to that in 2011?
Give a very brief answer. 0.99. What is the ratio of the Female students (as % of total students) of United Arab Emirates in 2010 to that in 2011?
Keep it short and to the point. 0.98. What is the difference between the highest and the second highest Female students (as % of total students) of Azerbaijan?
Ensure brevity in your answer.  0.35. What is the difference between the highest and the second highest Female students (as % of total students) in Barbados?
Make the answer very short. 0.01. What is the difference between the highest and the second highest Female students (as % of total students) in Bulgaria?
Offer a terse response. 0.63. What is the difference between the highest and the second highest Female students (as % of total students) of United Arab Emirates?
Give a very brief answer. 1.07. What is the difference between the highest and the lowest Female students (as % of total students) in Azerbaijan?
Your response must be concise. 1.7. What is the difference between the highest and the lowest Female students (as % of total students) in Barbados?
Your response must be concise. 0.65. What is the difference between the highest and the lowest Female students (as % of total students) in Bulgaria?
Provide a short and direct response. 1.01. What is the difference between the highest and the lowest Female students (as % of total students) in United Arab Emirates?
Your answer should be very brief. 5.8. 